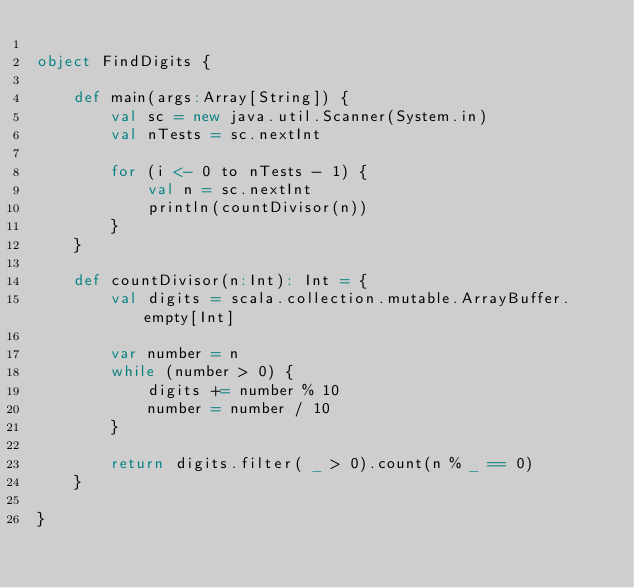<code> <loc_0><loc_0><loc_500><loc_500><_Scala_>
object FindDigits {

    def main(args:Array[String]) {
        val sc = new java.util.Scanner(System.in)
        val nTests = sc.nextInt
        
        for (i <- 0 to nTests - 1) {
            val n = sc.nextInt
            println(countDivisor(n))
        }
    }

    def countDivisor(n:Int): Int = {
        val digits = scala.collection.mutable.ArrayBuffer.empty[Int]
        
        var number = n
        while (number > 0) {
            digits += number % 10
            number = number / 10
        }
        
        return digits.filter( _ > 0).count(n % _ == 0)
    }

}
</code> 